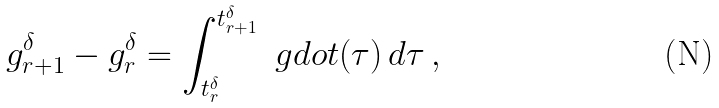Convert formula to latex. <formula><loc_0><loc_0><loc_500><loc_500>g _ { r + 1 } ^ { \delta } - g _ { r } ^ { \delta } = \int _ { t _ { r } ^ { \delta } } ^ { t _ { r + 1 } ^ { \delta } } \ g d o t ( \tau ) \, d \tau \, ,</formula> 